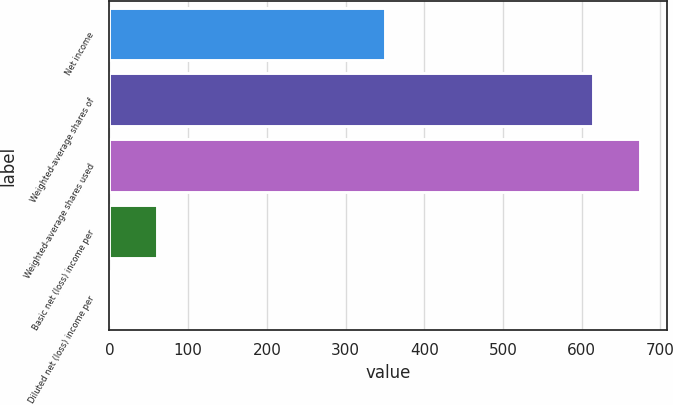<chart> <loc_0><loc_0><loc_500><loc_500><bar_chart><fcel>Net income<fcel>Weighted-average shares of<fcel>Weighted-average shares used<fcel>Basic net (loss) income per<fcel>Diluted net (loss) income per<nl><fcel>350.7<fcel>614.16<fcel>674.12<fcel>60.54<fcel>0.58<nl></chart> 